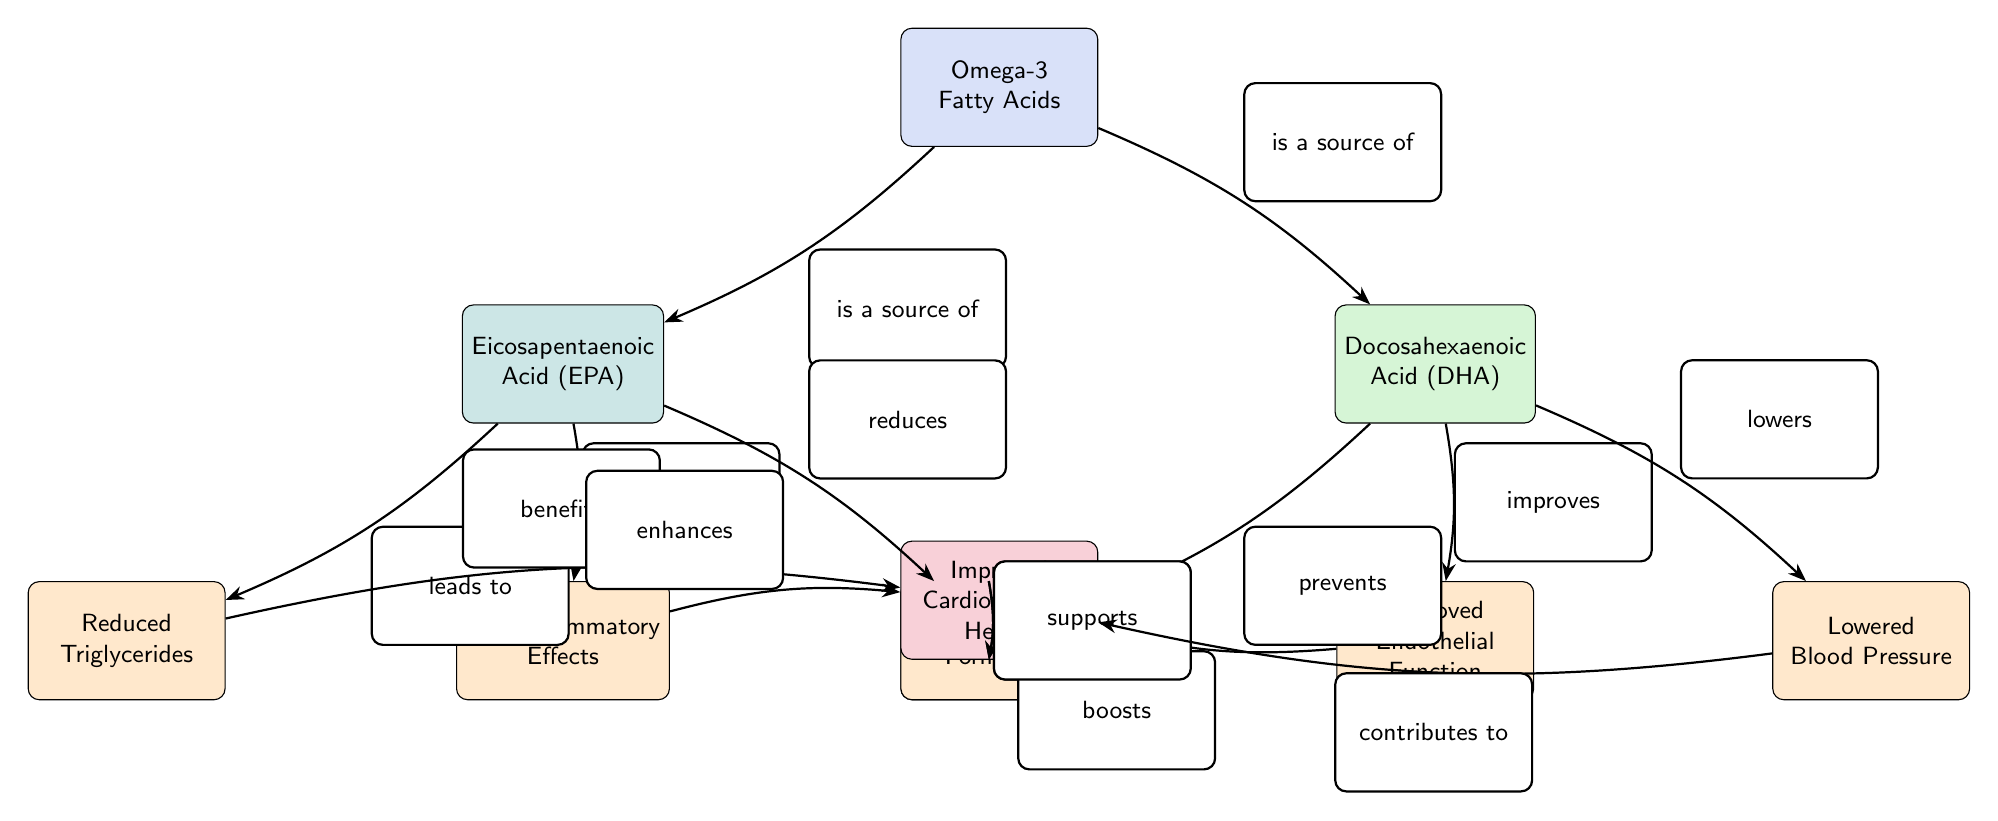What are the two main types of Omega-3 Fatty Acids shown in the diagram? The diagram identifies two main types of Omega-3 Fatty Acids, which are Eicosapentaenoic Acid (EPA) and Docosahexaenoic Acid (DHA). They are connected directly under the Omega-3 Fatty Acids node, indicating their source.
Answer: Eicosapentaenoic Acid (EPA), Docosahexaenoic Acid (DHA) How many effects of Eicosapentaenoic Acid (EPA) are listed in the diagram? The diagram includes three effects of Eicosapentaenoic Acid (EPA): Reduced Triglycerides, Anti-inflammatory Effects, and Reduced Arrhythmias. By counting these nodes beneath EPA, we arrive at the total.
Answer: 3 What is the relationship between DHA and Blood Pressure? The diagram indicates that DHA lowers blood pressure, as represented by the edge labeled "lowers" connecting DHA to Blood Pressure. This clearly shows the specific action attributed to DHA regarding blood pressure levels.
Answer: Lowers Which factor contributes to improved cardiovascular health? The diagram shows multiple factors contributing to improved cardiovascular health, such as Reduced Triglycerides, Reduced Plaque Formation, and Lowered Blood Pressure. Each of these nodes points towards the main health outcome node.
Answer: Reduced Triglycerides, Reduced Plaque Formation, Lowered Blood Pressure What color represents the health impact of Omega-3 Fatty Acids in the diagram? The diagram uses a distinct color for the health impact nodes, specifically the health-related node labeled "Improved Cardiovascular Health," which is filled with a shade of red (RGB 220,20,60).
Answer: RGB 220,20,60 How many nodes represent effects of DHA compared to those of EPA? The diagram shows three effects stemming from DHA (Reduced Plaque Formation, Improved Endothelial Function, and Lowered Blood Pressure) and three effects stemming from EPA (Reduced Triglycerides, Anti-inflammatory Effects, and Reduced Arrhythmias). Thus, both DHA and EPA have the same number of effect nodes.
Answer: 3 effects each Which effect does EPA contribute to that is related to inflammation? The diagram indicates that EPA contributes to the Anti-inflammatory Effects. This is specifically noted by the edge labeled "contributes to," which leads directly from EPA to the corresponding effect node.
Answer: Anti-inflammatory Effects What is the final outcome of the biochemical pathways related to Omega-3 Fatty Acids? The final outcome represented in the diagram is "Improved Cardiovascular Health," which is shown as resulting from various contributing factors evaluated through the connections from the effects nodes to the health outcome node.
Answer: Improved Cardiovascular Health 